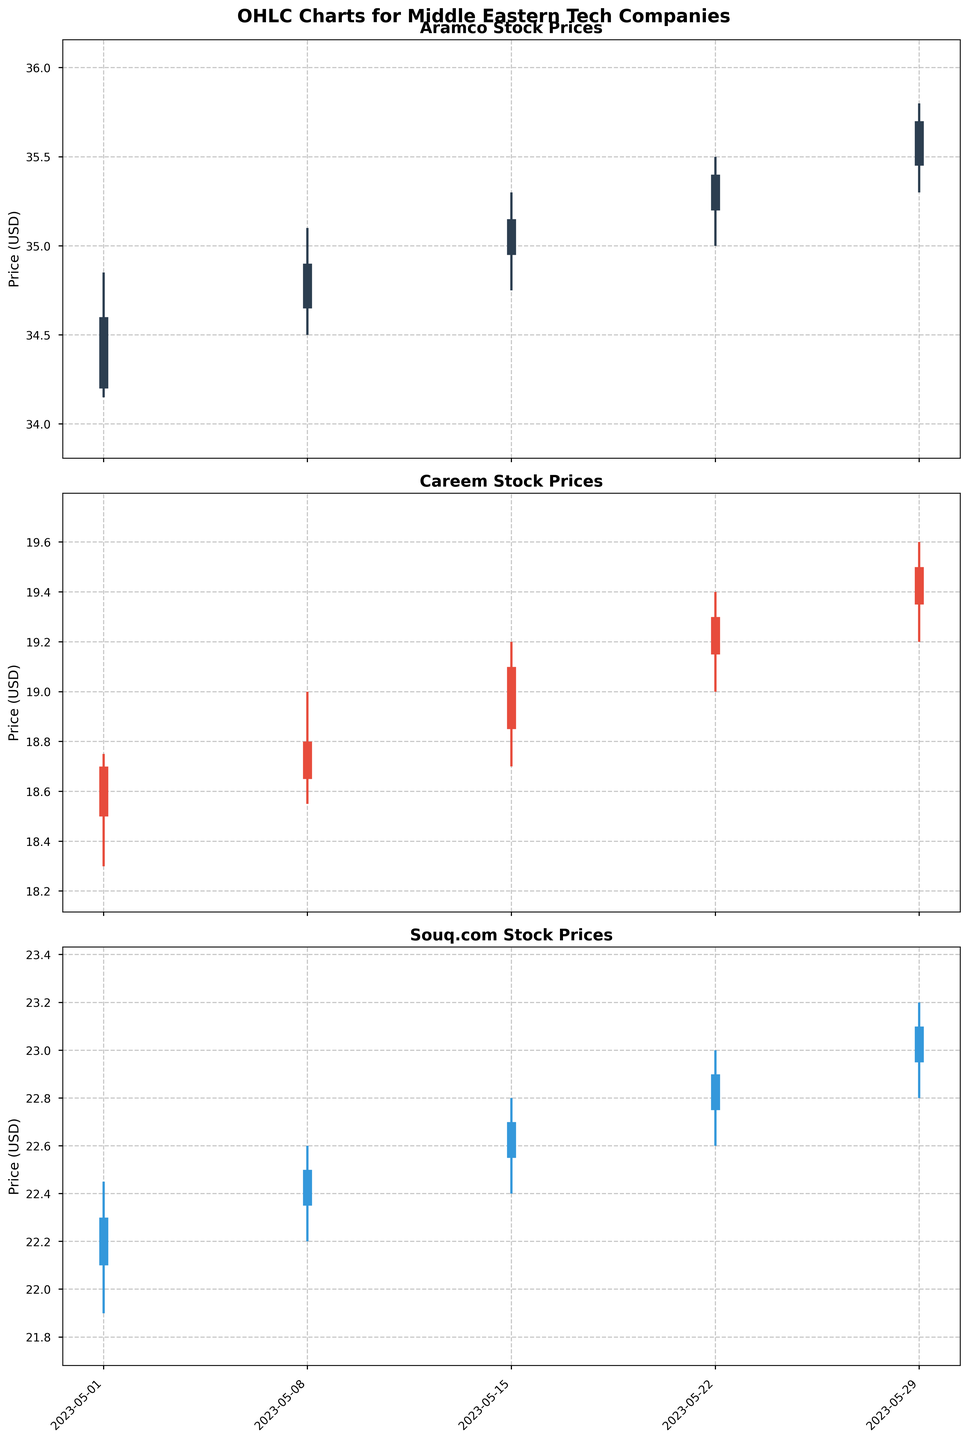What is the highest stock price reached by Aramco over the past month? The highest stock price is indicated by the maximum value on the "High" column for Aramco. From the data, on 2023-05-29 Aramco reached a high price of $35.80.
Answer: $35.80 Which company had the lowest stock price on 2023-05-08? To determine the lowest stock price on 2023-05-08, we look at the "Low" values for each company on that date. Aramco had a low of $34.50, Careem had a low of $18.55, and Souq.com had a low of $22.20. The lowest among these is Careem with $18.55.
Answer: Careem By how much did Souq.com's closing price increase from 2023-05-22 to 2023-05-29? The closing price for Souq.com on 2023-05-22 was $22.90 and on 2023-05-29 was $23.10. The increase is $23.10 - $22.90 = $0.20.
Answer: $0.20 What is the average closing price of Careem over the past month? The closing prices of Careem are $18.70, $18.80, $19.10, $19.30, and $19.50. The sum of these values is $95.40, and there are 5 data points. The average is $95.40 / 5 = $19.08.
Answer: $19.08 Which company shows the most volatile stock prices based on the high-low range over the past month? To determine volatility, we calculate the high-low range for each company. Aramco's ranges are $0.70, $0.60, $0.55, $0.50, and $0.50; Careem's ranges are $0.45, $0.45, $0.50, $0.40, and $0.40; Souq.com's ranges are $0.55, $0.40, $0.40, $0.40, and $0.40. Aramco has the highest ranges.
Answer: Aramco On which date did Aramco have its highest closing price? By examining the closing prices for Aramco, the highest closing price was $35.70, which occurred on 2023-05-29.
Answer: 2023-05-29 How does Careem's opening price trend change over the past month? From the data, Careem’s opening prices over the dates are $18.50, $18.65, $18.85, $19.15, and $19.35. This indicates a trend of increasing opening prices over the past month.
Answer: Increasing Between Aramco and Souq.com, which company had a higher closing price on 2023-05-15? On 2023-05-15, Aramco's closing price was $35.15 and Souq.com's was $22.70. Aramco had the higher closing price.
Answer: Aramco What is the difference between the highest and lowest closing prices of Souq.com over the past month? The highest closing price for Souq.com is $23.10 and the lowest is $22.30. The difference is $23.10 - $22.30 = $0.80.
Answer: $0.80 